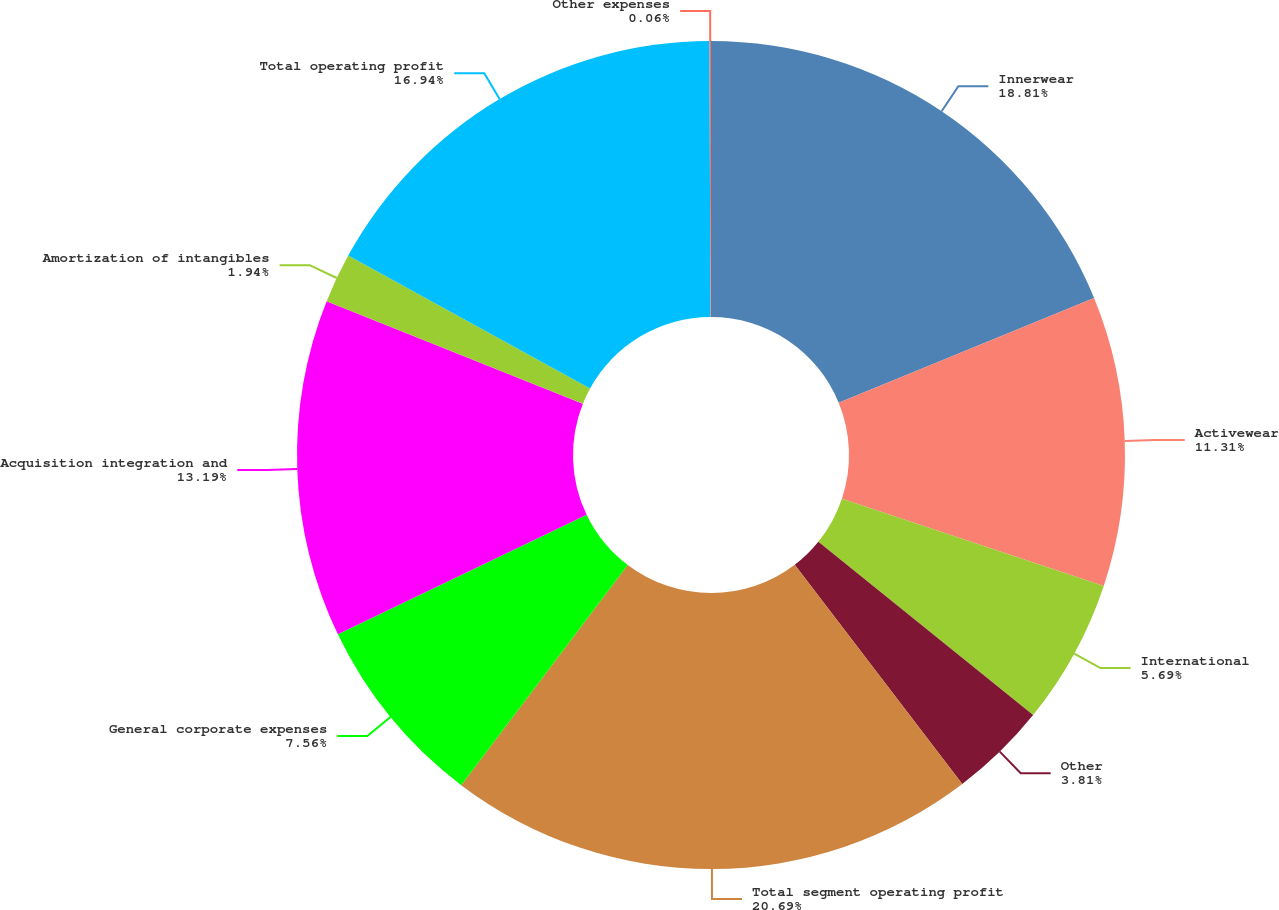Convert chart. <chart><loc_0><loc_0><loc_500><loc_500><pie_chart><fcel>Innerwear<fcel>Activewear<fcel>International<fcel>Other<fcel>Total segment operating profit<fcel>General corporate expenses<fcel>Acquisition integration and<fcel>Amortization of intangibles<fcel>Total operating profit<fcel>Other expenses<nl><fcel>18.81%<fcel>11.31%<fcel>5.69%<fcel>3.81%<fcel>20.69%<fcel>7.56%<fcel>13.19%<fcel>1.94%<fcel>16.94%<fcel>0.06%<nl></chart> 